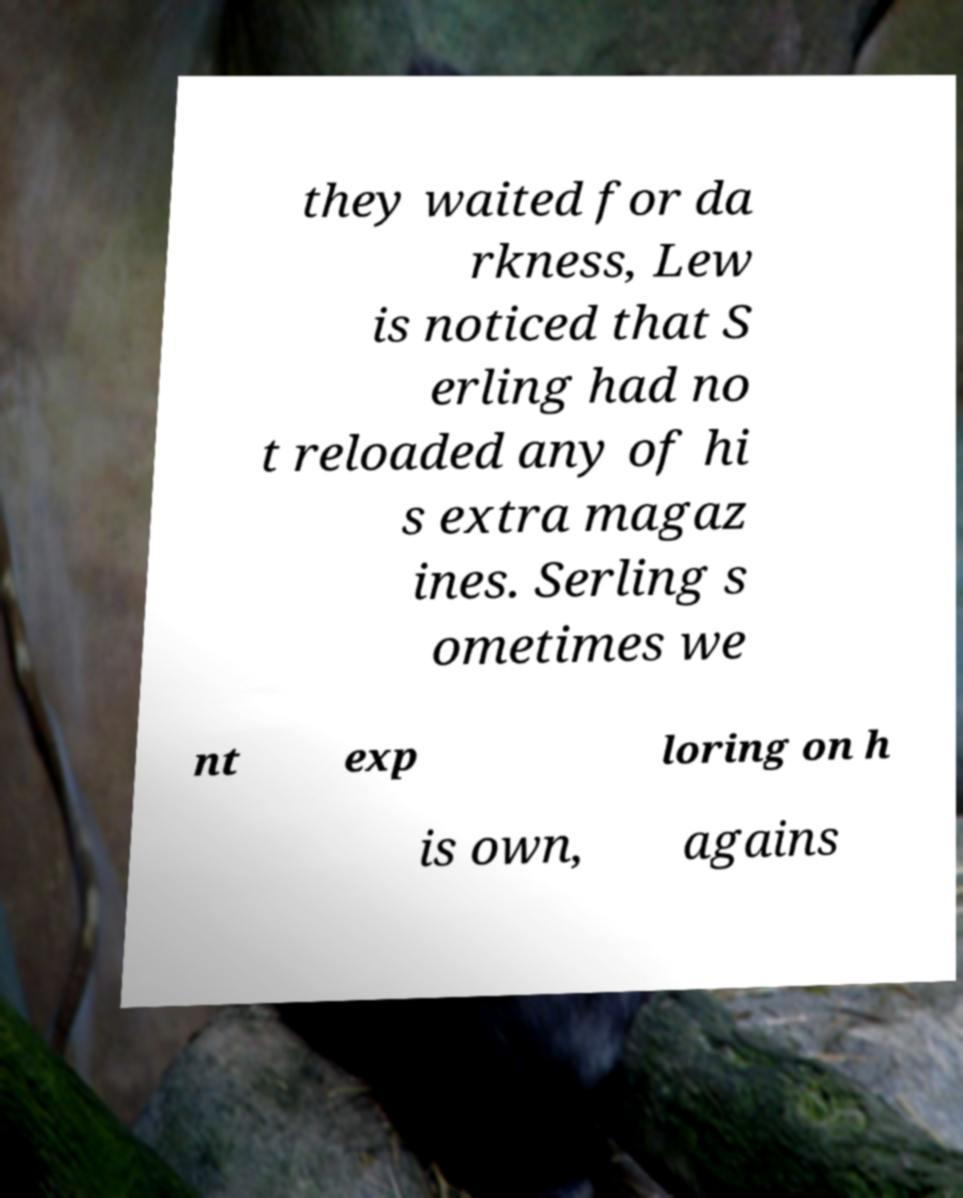Please read and relay the text visible in this image. What does it say? they waited for da rkness, Lew is noticed that S erling had no t reloaded any of hi s extra magaz ines. Serling s ometimes we nt exp loring on h is own, agains 